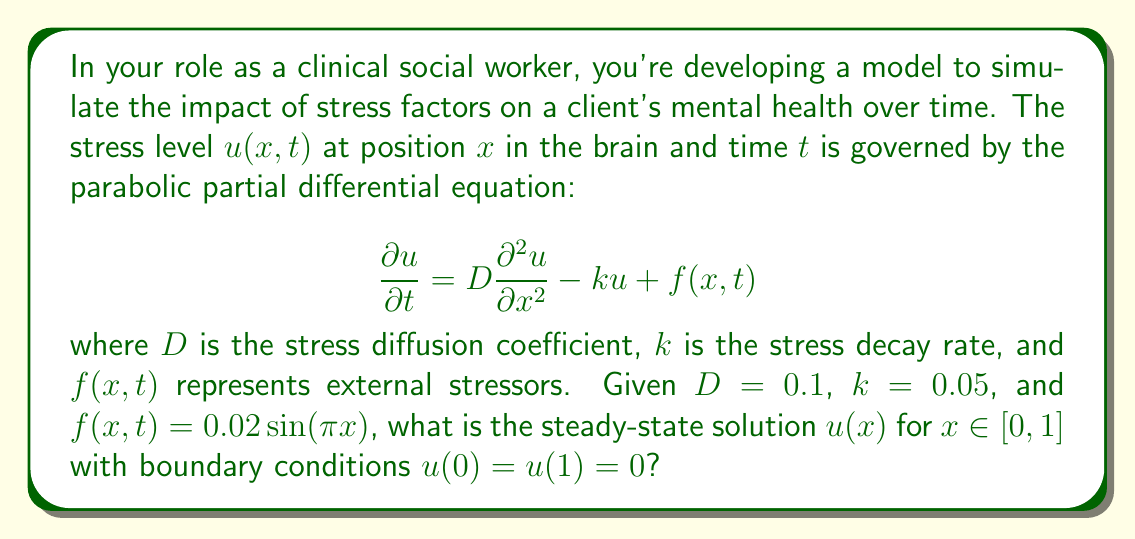Give your solution to this math problem. To solve this problem, we'll follow these steps:

1) For the steady-state solution, $\frac{\partial u}{\partial t} = 0$, so our equation becomes:

   $$0 = D\frac{d^2 u}{dx^2} - ku + f(x)$$

2) Substituting the given values:

   $$0 = 0.1\frac{d^2 u}{dx^2} - 0.05u + 0.02\sin(\pi x)$$

3) Rearranging:

   $$\frac{d^2 u}{dx^2} - 0.5u = -0.2\sin(\pi x)$$

4) The general solution to this equation is of the form:

   $$u(x) = A\sinh(\sqrt{0.5}x) + B\cosh(\sqrt{0.5}x) + C\sin(\pi x)$$

5) Substituting this into the original equation:

   $$0.1(-0.5A\sinh(\sqrt{0.5}x) - 0.5B\cosh(\sqrt{0.5}x) - \pi^2C\sin(\pi x)) - 0.05(A\sinh(\sqrt{0.5}x) + B\cosh(\sqrt{0.5}x) + C\sin(\pi x)) + 0.02\sin(\pi x) = 0$$

6) Comparing coefficients of $\sin(\pi x)$:

   $$-0.1\pi^2C - 0.05C + 0.02 = 0$$
   $$C = \frac{0.02}{0.1\pi^2 + 0.05} \approx 0.0201$$

7) Applying boundary conditions $u(0) = u(1) = 0$:

   $$u(0) = B + 0.0201\sin(0) = 0 \implies B = 0$$
   $$u(1) = A\sinh(\sqrt{0.5}) + 0.0201\sin(\pi) = 0 \implies A = 0$$

8) Therefore, the steady-state solution is:

   $$u(x) = 0.0201\sin(\pi x)$$
Answer: $u(x) = 0.0201\sin(\pi x)$ 